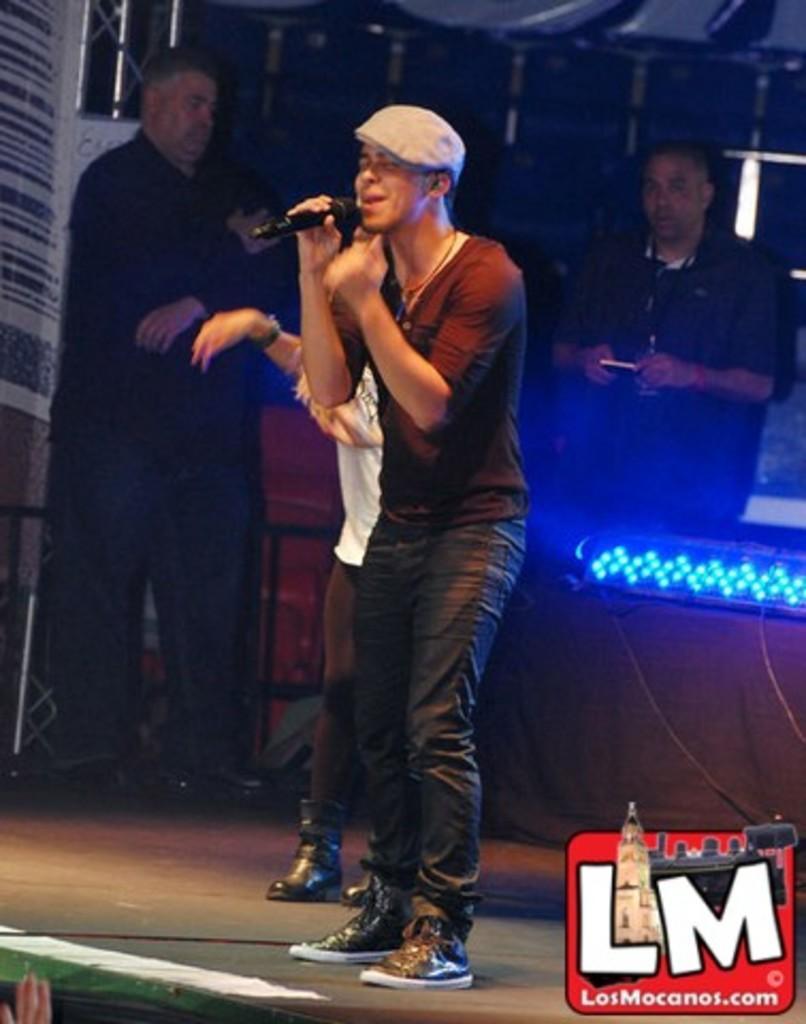In one or two sentences, can you explain what this image depicts? In this image we can see a man is standing on the stage and holding a mic in the hand. In the background there are few persons, rods, lights, cables and objects. At the bottom on the right side corner there is a logo and text written on the image. 